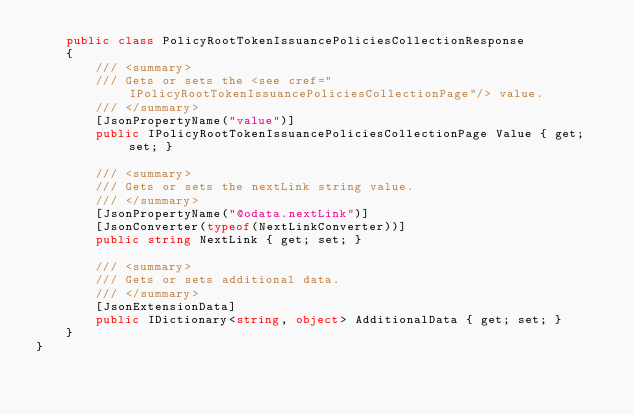<code> <loc_0><loc_0><loc_500><loc_500><_C#_>    public class PolicyRootTokenIssuancePoliciesCollectionResponse
    {
        /// <summary>
        /// Gets or sets the <see cref="IPolicyRootTokenIssuancePoliciesCollectionPage"/> value.
        /// </summary>
        [JsonPropertyName("value")]
        public IPolicyRootTokenIssuancePoliciesCollectionPage Value { get; set; }

        /// <summary>
        /// Gets or sets the nextLink string value.
        /// </summary>
        [JsonPropertyName("@odata.nextLink")]
        [JsonConverter(typeof(NextLinkConverter))]
        public string NextLink { get; set; }

        /// <summary>
        /// Gets or sets additional data.
        /// </summary>
        [JsonExtensionData]
        public IDictionary<string, object> AdditionalData { get; set; }
    }
}
</code> 